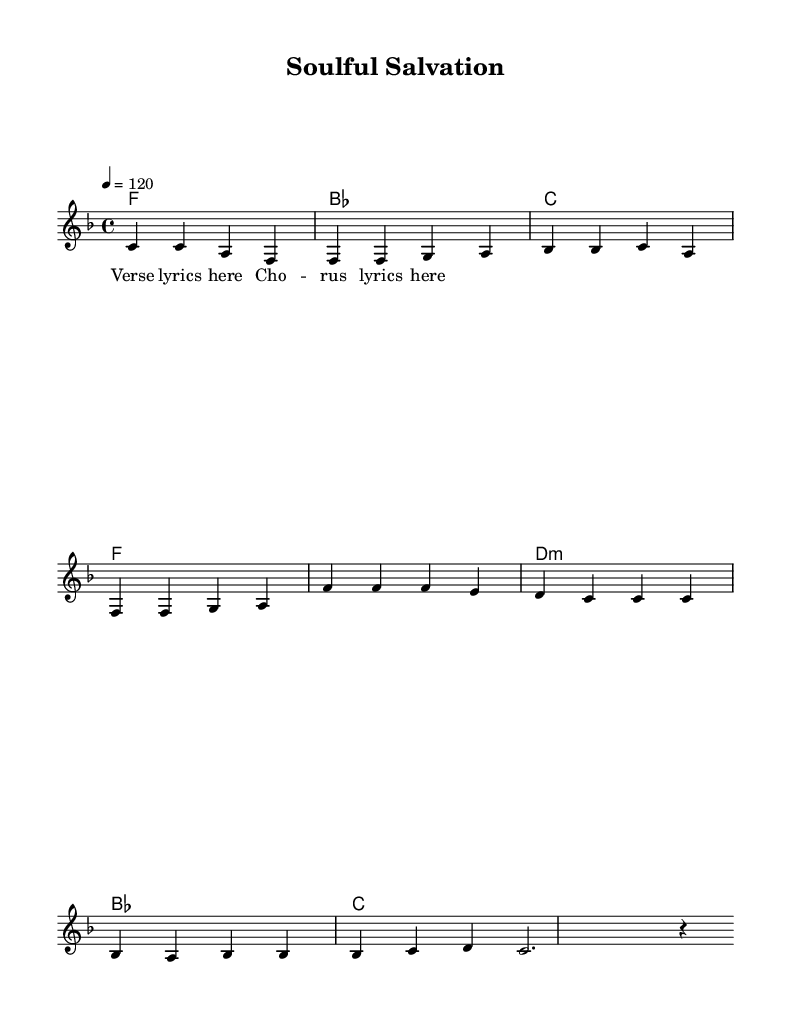What is the key signature of this music? The key signature is F major, which has one flat (B flat). This is indicated at the beginning of the staff.
Answer: F major What is the time signature of this piece? The time signature is 4/4, as indicated by the notation at the start of the score. This means there are four beats in each measure and the quarter note gets one beat.
Answer: 4/4 What is the tempo marking for the music? The tempo marking is 120 beats per minute, indicated by the number "4 = 120" at the beginning of the score. This specifies how fast the piece should be played.
Answer: 120 How many measures are in the verse section? The verse section has four measures, as indicated by the grouping of notes following the verse lyrics in the melody part. Each measure is separated by a vertical line.
Answer: Four Which chord comes after the second measure of the verse? After the second measure of the verse, the chord is C major, as indicated in the chord progression under the melody line.
Answer: C major What is the first note of the chorus? The first note of the chorus is F, which is represented as "f'" in the melody part, indicating it is in the higher octave.
Answer: F What is the musical genre of this piece? The musical genre is disco, specifically gospel-influenced disco due to the uplifting dance rhythms that blend with spiritual themes. This genre is typical for compositions that encourage dancing while offering a spiritual message.
Answer: Disco 